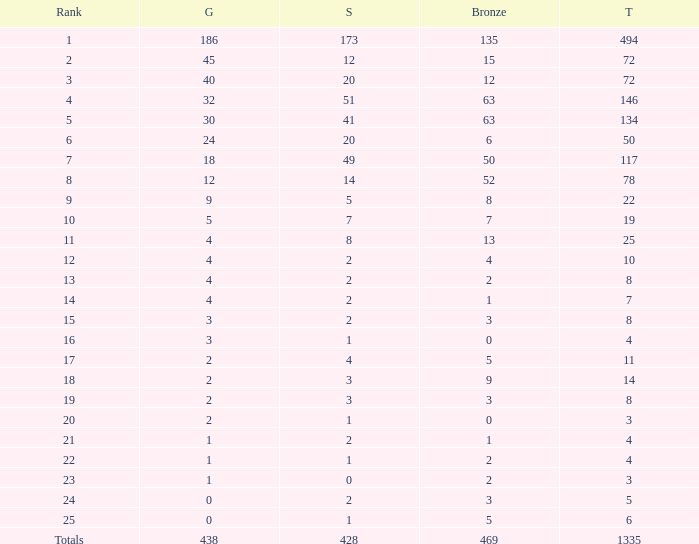What is the number of bronze medals when the total medals were 78 and there were less than 12 golds? None. 